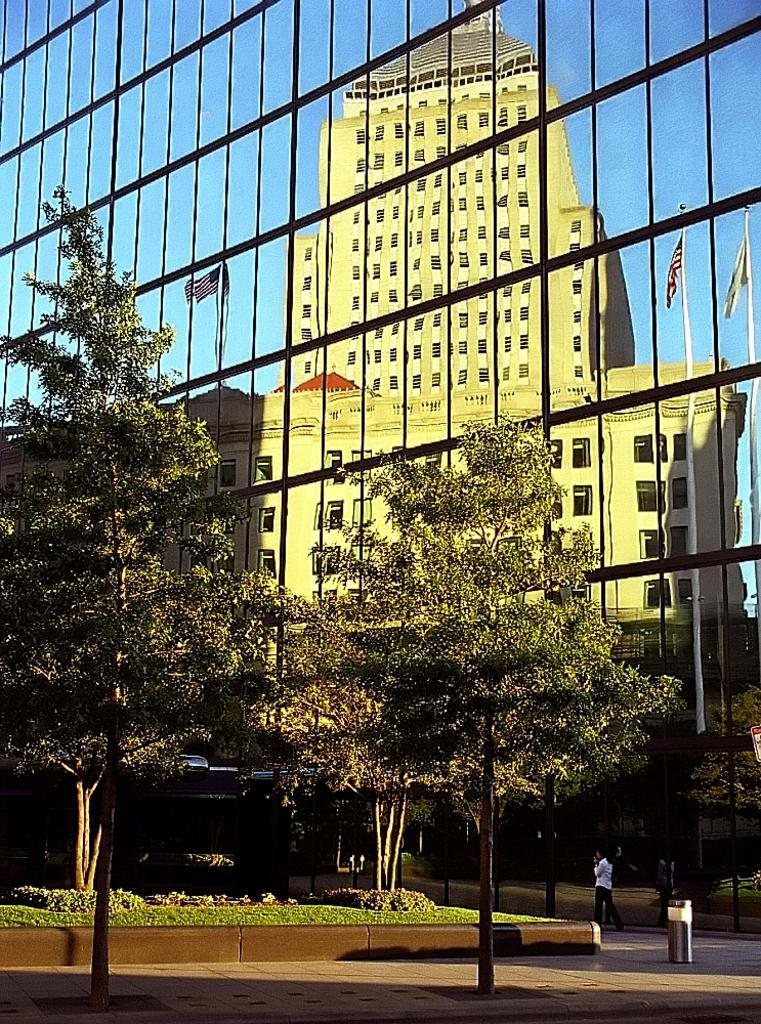What type of structure is visible in the image? There is a building in the image. What can be seen flying near the building? There are flags in the image. What are the flags attached to? Flag posts are present in the image. What type of vegetation is visible in the image? There are trees, bushes, and plants visible in the image. What is the condition of the sky in the image? The sky is visible in the image. Are there any people present in the image? Yes, there are persons on the road in the image. What type of waste disposal containers are visible in the image? Bins are visible in the image. What type of liquid is being poured from the hat in the image? There is no hat or liquid present in the image. How does love affect the persons on the road in the image? The image does not depict any emotions or relationships between the persons on the road, so it is not possible to determine how love might affect them. 